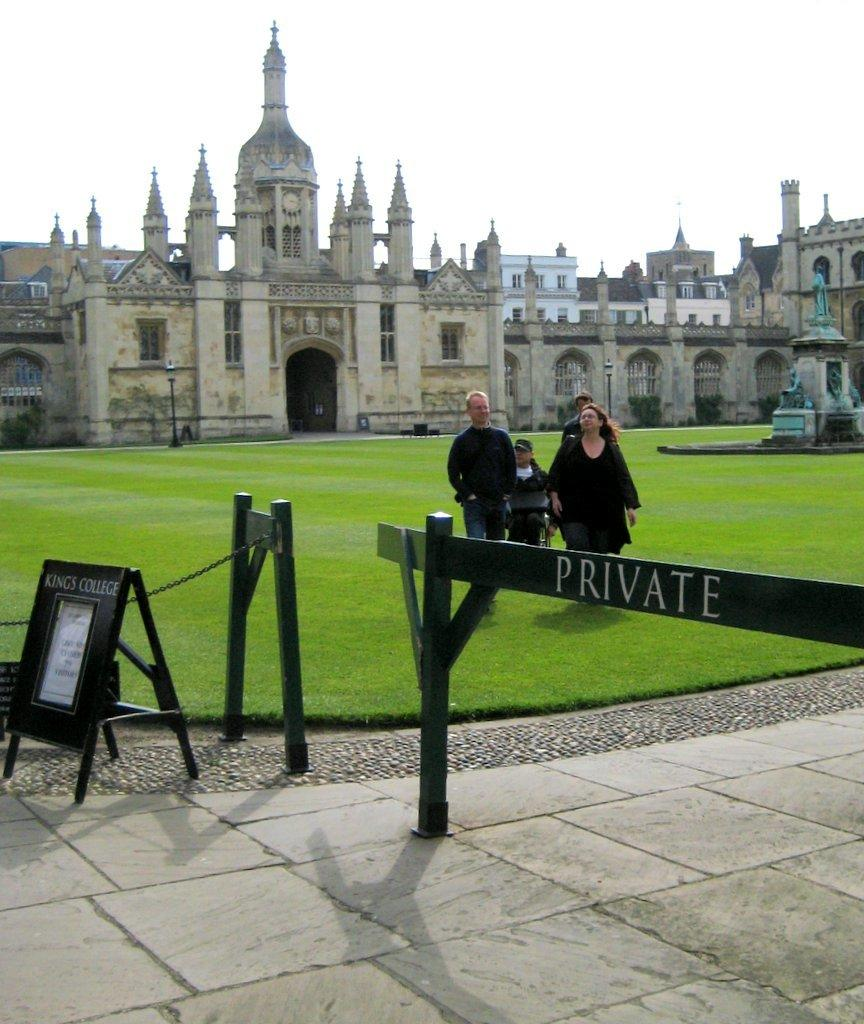What can be seen at the base of the image? The ground is visible in the image. What is placed on the ground? There is a board on the ground. What type of barrier is present in the image? There is a fence in the image. What is located on the ground in the image? There is an object on the ground. What can be seen in the distance in the image? There are people, grass, buildings, and some unspecified objects in the background of the image. What is visible above the background of the image? The sky is visible in the background of the image. What type of paper is being used by the people in the image? There is no paper visible in the image; it only shows a board, fence, and some unspecified objects in the background. What color is the skin of the people in the image? There are no people close enough to see their skin color in the image. 